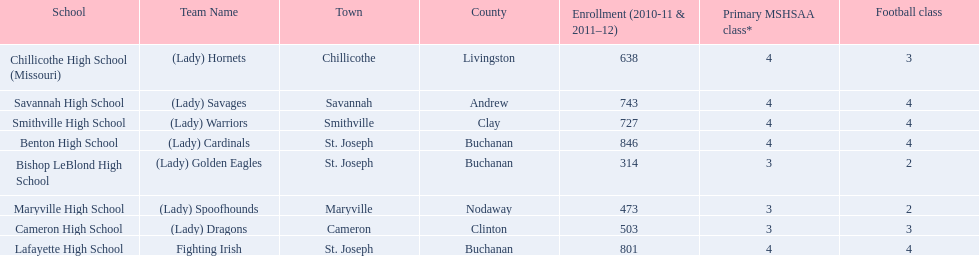What were the schools enrolled in 2010-2011 Benton High School, Bishop LeBlond High School, Cameron High School, Chillicothe High School (Missouri), Lafayette High School, Maryville High School, Savannah High School, Smithville High School. How many were enrolled in each? 846, 314, 503, 638, 801, 473, 743, 727. Which is the lowest number? 314. Which school had this number of students? Bishop LeBlond High School. 